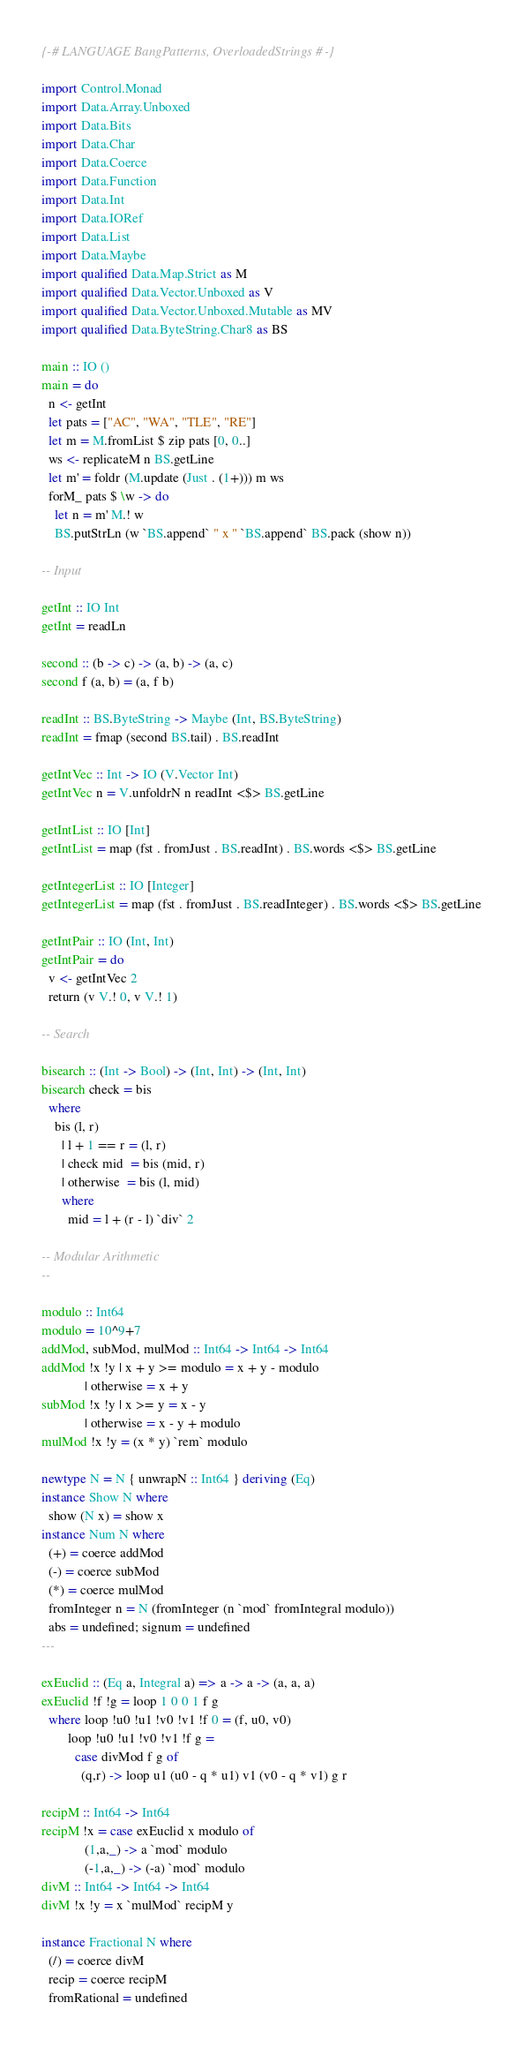<code> <loc_0><loc_0><loc_500><loc_500><_Haskell_>{-# LANGUAGE BangPatterns, OverloadedStrings #-}

import Control.Monad
import Data.Array.Unboxed
import Data.Bits
import Data.Char
import Data.Coerce
import Data.Function
import Data.Int 
import Data.IORef
import Data.List
import Data.Maybe
import qualified Data.Map.Strict as M
import qualified Data.Vector.Unboxed as V
import qualified Data.Vector.Unboxed.Mutable as MV
import qualified Data.ByteString.Char8 as BS

main :: IO ()
main = do
  n <- getInt
  let pats = ["AC", "WA", "TLE", "RE"]
  let m = M.fromList $ zip pats [0, 0..]
  ws <- replicateM n BS.getLine
  let m' = foldr (M.update (Just . (1+))) m ws
  forM_ pats $ \w -> do
    let n = m' M.! w
    BS.putStrLn (w `BS.append` " x " `BS.append` BS.pack (show n))

-- Input

getInt :: IO Int
getInt = readLn

second :: (b -> c) -> (a, b) -> (a, c)
second f (a, b) = (a, f b)

readInt :: BS.ByteString -> Maybe (Int, BS.ByteString)
readInt = fmap (second BS.tail) . BS.readInt

getIntVec :: Int -> IO (V.Vector Int)
getIntVec n = V.unfoldrN n readInt <$> BS.getLine

getIntList :: IO [Int]
getIntList = map (fst . fromJust . BS.readInt) . BS.words <$> BS.getLine

getIntegerList :: IO [Integer]
getIntegerList = map (fst . fromJust . BS.readInteger) . BS.words <$> BS.getLine

getIntPair :: IO (Int, Int)
getIntPair = do
  v <- getIntVec 2
  return (v V.! 0, v V.! 1)

-- Search

bisearch :: (Int -> Bool) -> (Int, Int) -> (Int, Int)
bisearch check = bis
  where
    bis (l, r)
      | l + 1 == r = (l, r)
      | check mid  = bis (mid, r)
      | otherwise  = bis (l, mid)
      where
        mid = l + (r - l) `div` 2

-- Modular Arithmetic
--
 
modulo :: Int64
modulo = 10^9+7
addMod, subMod, mulMod :: Int64 -> Int64 -> Int64
addMod !x !y | x + y >= modulo = x + y - modulo
             | otherwise = x + y
subMod !x !y | x >= y = x - y
             | otherwise = x - y + modulo
mulMod !x !y = (x * y) `rem` modulo

newtype N = N { unwrapN :: Int64 } deriving (Eq)
instance Show N where
  show (N x) = show x
instance Num N where
  (+) = coerce addMod
  (-) = coerce subMod
  (*) = coerce mulMod
  fromInteger n = N (fromInteger (n `mod` fromIntegral modulo))
  abs = undefined; signum = undefined
---
 
exEuclid :: (Eq a, Integral a) => a -> a -> (a, a, a)
exEuclid !f !g = loop 1 0 0 1 f g
  where loop !u0 !u1 !v0 !v1 !f 0 = (f, u0, v0)
        loop !u0 !u1 !v0 !v1 !f g =
          case divMod f g of
            (q,r) -> loop u1 (u0 - q * u1) v1 (v0 - q * v1) g r
 
recipM :: Int64 -> Int64
recipM !x = case exEuclid x modulo of
             (1,a,_) -> a `mod` modulo
             (-1,a,_) -> (-a) `mod` modulo
divM :: Int64 -> Int64 -> Int64
divM !x !y = x `mulMod` recipM y
 
instance Fractional N where
  (/) = coerce divM
  recip = coerce recipM
  fromRational = undefined</code> 